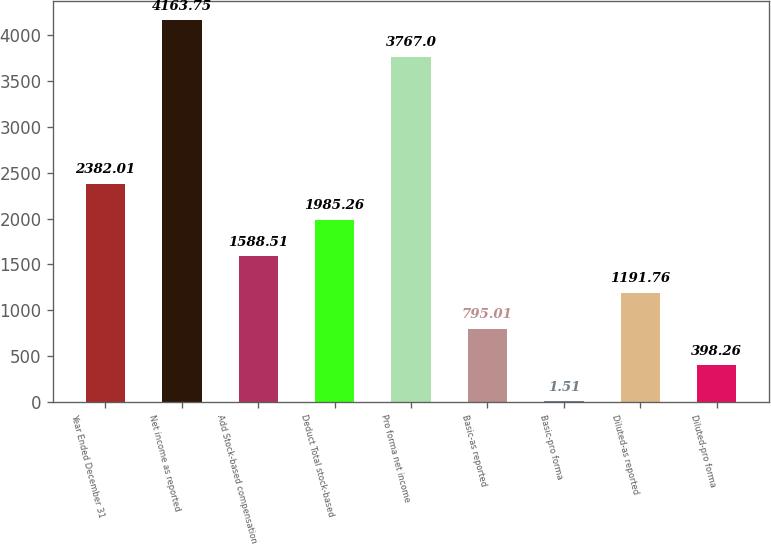Convert chart. <chart><loc_0><loc_0><loc_500><loc_500><bar_chart><fcel>Year Ended December 31<fcel>Net income as reported<fcel>Add Stock-based compensation<fcel>Deduct Total stock-based<fcel>Pro forma net income<fcel>Basic-as reported<fcel>Basic-pro forma<fcel>Diluted-as reported<fcel>Diluted-pro forma<nl><fcel>2382.01<fcel>4163.75<fcel>1588.51<fcel>1985.26<fcel>3767<fcel>795.01<fcel>1.51<fcel>1191.76<fcel>398.26<nl></chart> 